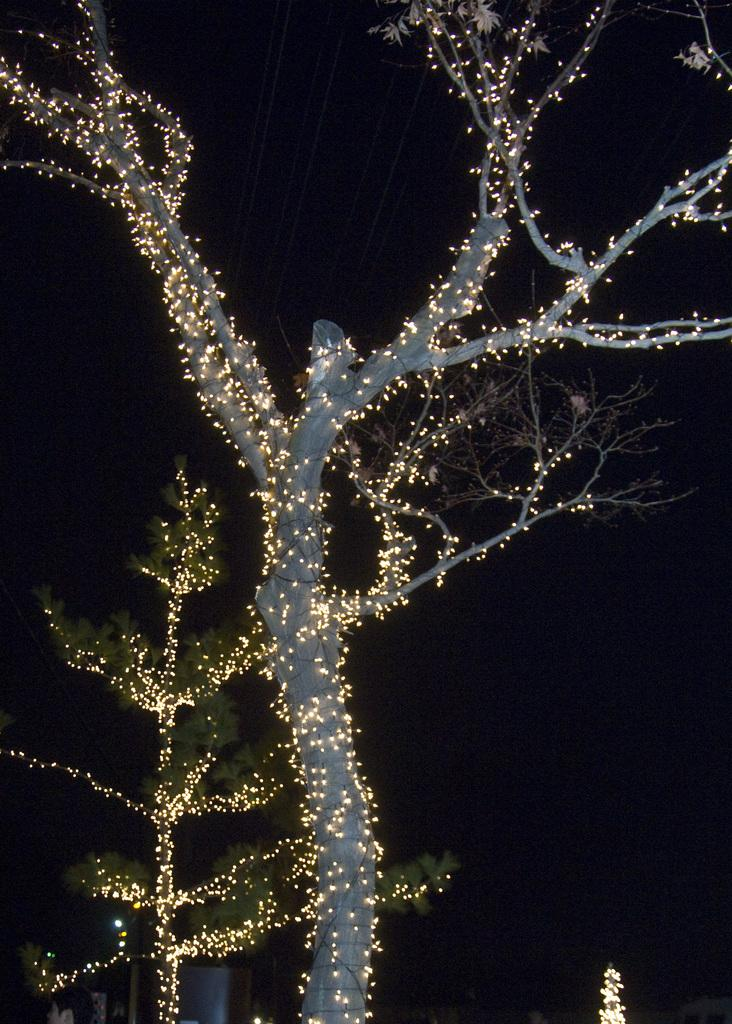What is present in the image? There is a tree in the image. What feature does the tree have? The tree has lights. Where was the image taken? The image was taken outside. What type of scarf is wrapped around the tree in the image? There is no scarf present in the image; the tree has lights instead. 